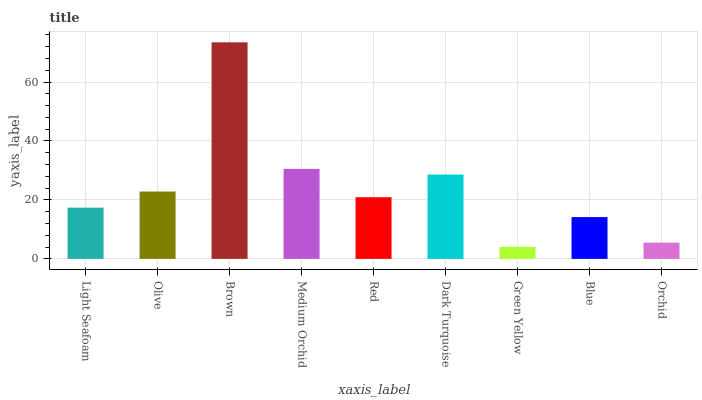Is Olive the minimum?
Answer yes or no. No. Is Olive the maximum?
Answer yes or no. No. Is Olive greater than Light Seafoam?
Answer yes or no. Yes. Is Light Seafoam less than Olive?
Answer yes or no. Yes. Is Light Seafoam greater than Olive?
Answer yes or no. No. Is Olive less than Light Seafoam?
Answer yes or no. No. Is Red the high median?
Answer yes or no. Yes. Is Red the low median?
Answer yes or no. Yes. Is Blue the high median?
Answer yes or no. No. Is Orchid the low median?
Answer yes or no. No. 